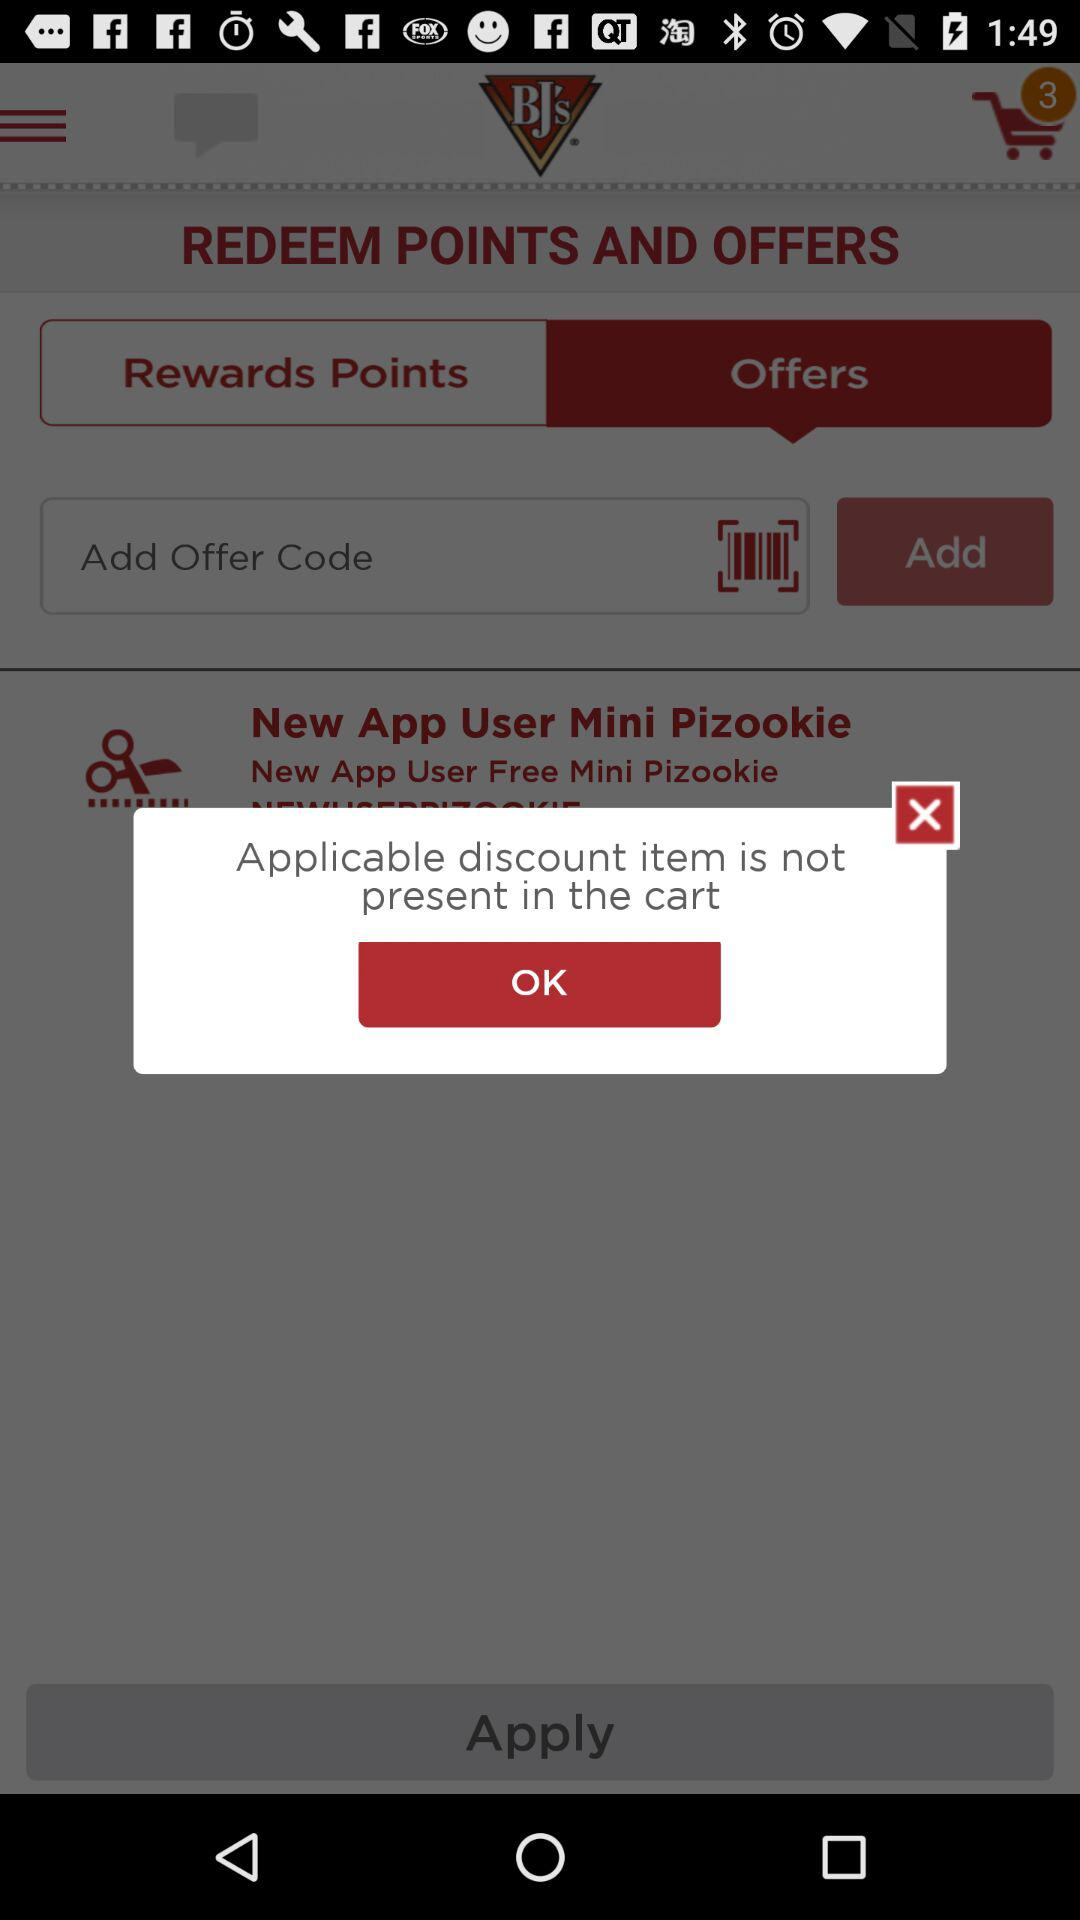How many notifications are received in a cart? There are 3 notifications. 